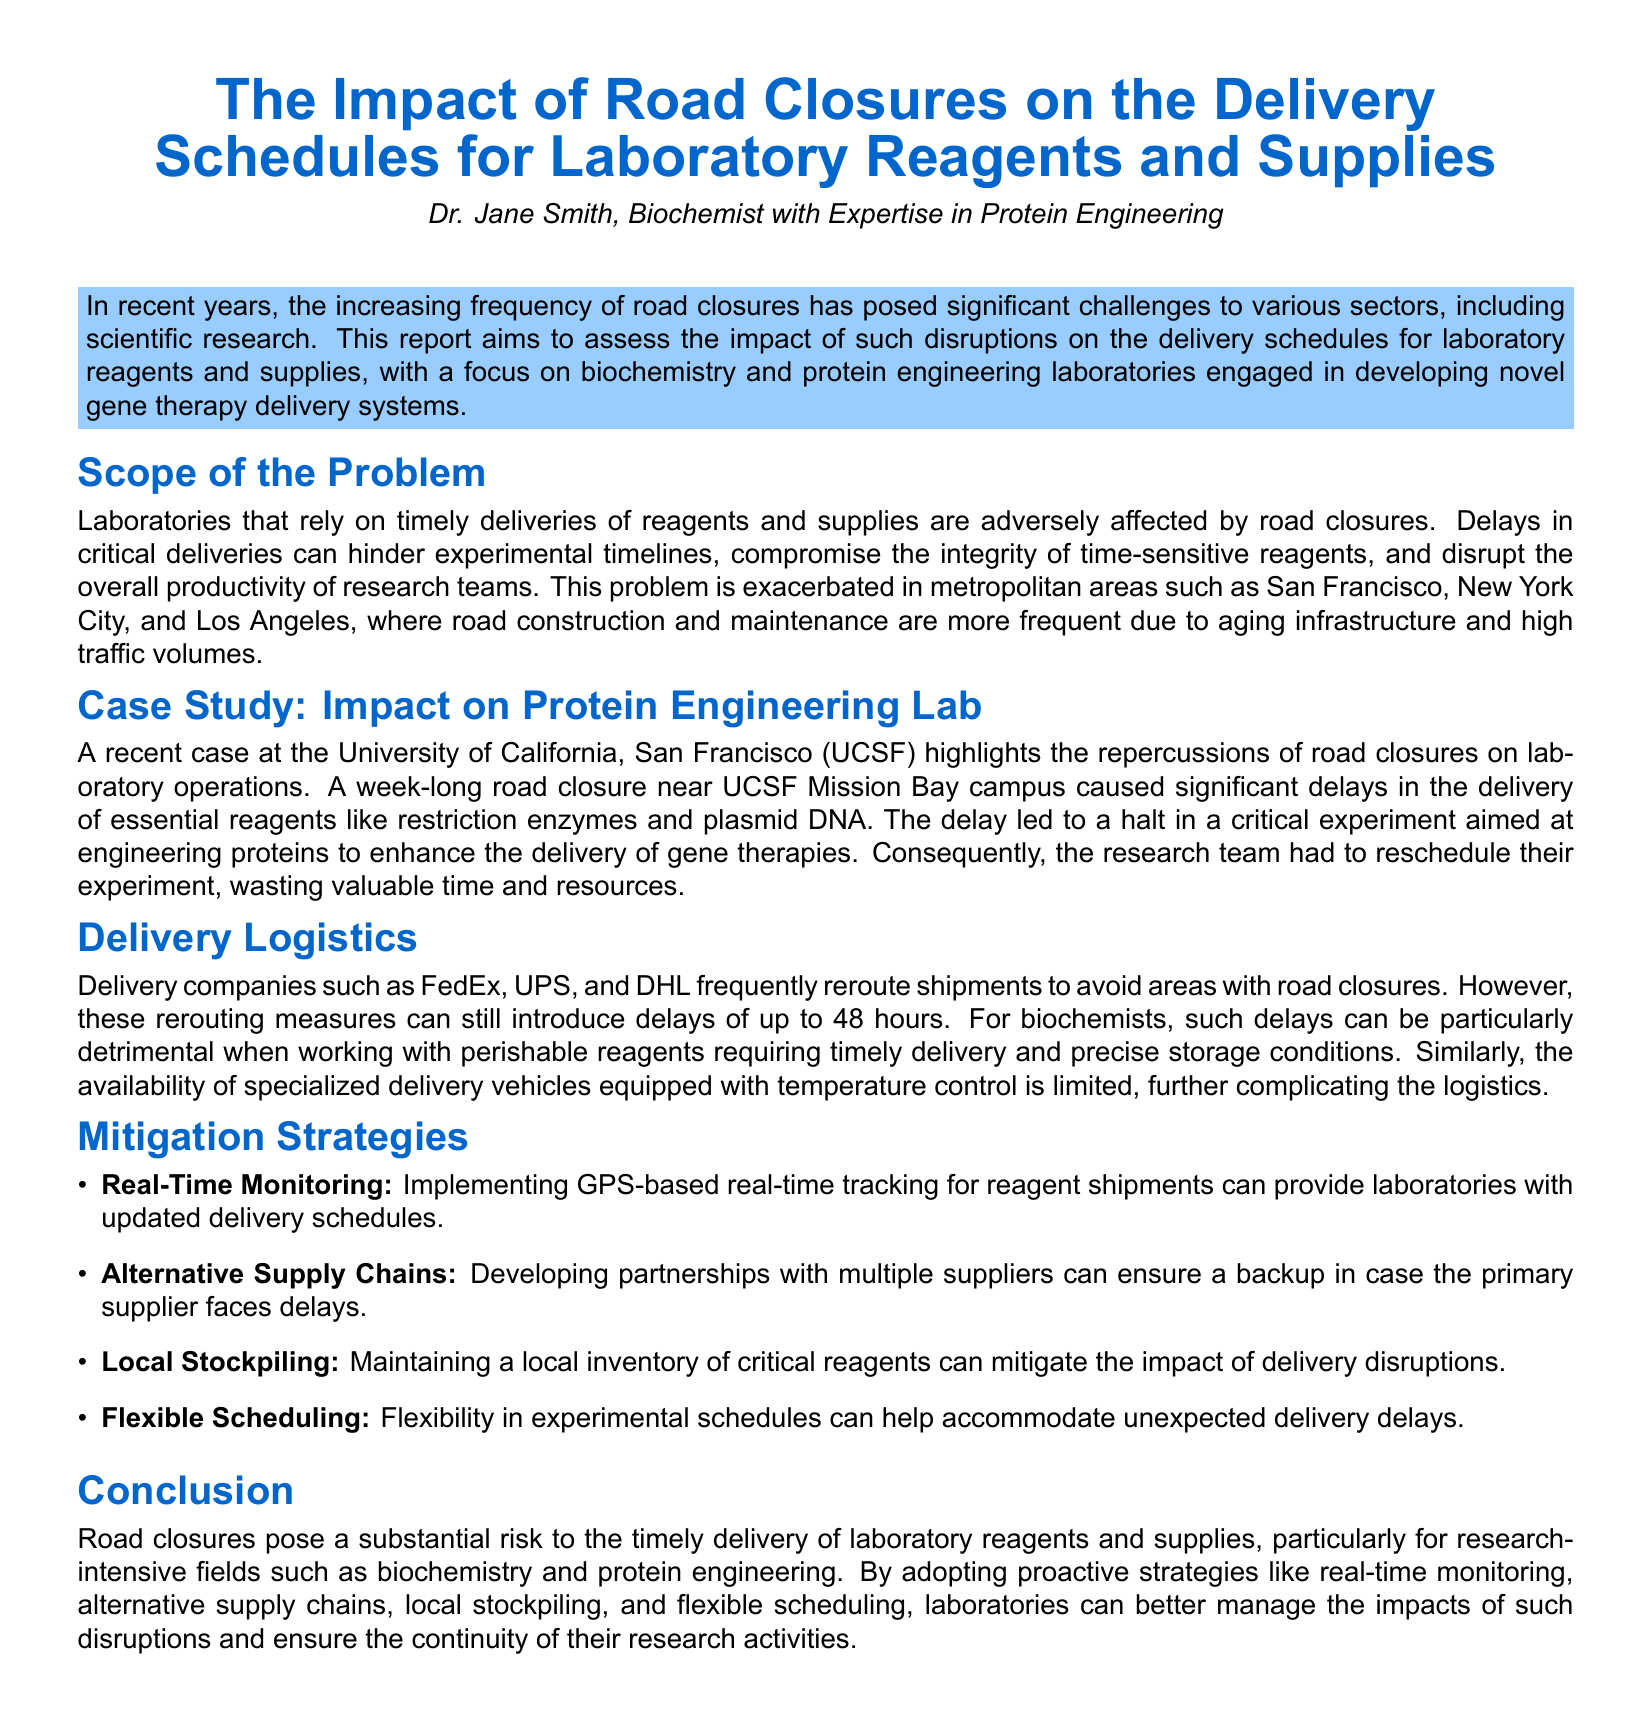What is the focus of the report? The report assesses the impact of road closures on the delivery schedules for laboratory reagents and supplies, particularly in the field of biochemistry and protein engineering.
Answer: biochemistry and protein engineering What is an essential reagent mentioned in the case study? The case study at UCSF highlights the delays in the delivery of essential reagents such as restriction enzymes and plasmid DNA.
Answer: restriction enzymes How long was the road closure near UCSF? The duration of the road closure near UCSF that impacted delivery schedules was one week.
Answer: one week What is one mitigation strategy suggested in the report? The report suggests several mitigation strategies, one of which is implementing GPS-based real-time tracking for reagent shipments.
Answer: Real-Time Monitoring What type of delays can delivery companies introduce due to rerouting? The document mentions that rerouting measures can introduce delays of up to 48 hours.
Answer: 48 hours Which metropolitan areas are noted for frequent road closures? The report specifically mentions metropolitan areas such as San Francisco, New York City, and Los Angeles as facing frequent road closures.
Answer: San Francisco, New York City, Los Angeles What was affected due to delays in reagent delivery? The delays in the delivery of essential reagents led to a halt in a critical experiment at UCSF focused on engineering proteins.
Answer: a halt in a critical experiment What can laboratories maintain to mitigate the impact of delivery disruptions? One suggested strategy is for laboratories to maintain a local inventory of critical reagents to mitigate delivery disruptions.
Answer: local inventory Which delivery companies are mentioned in the document? The document references several delivery companies including FedEx, UPS, and DHL.
Answer: FedEx, UPS, DHL 